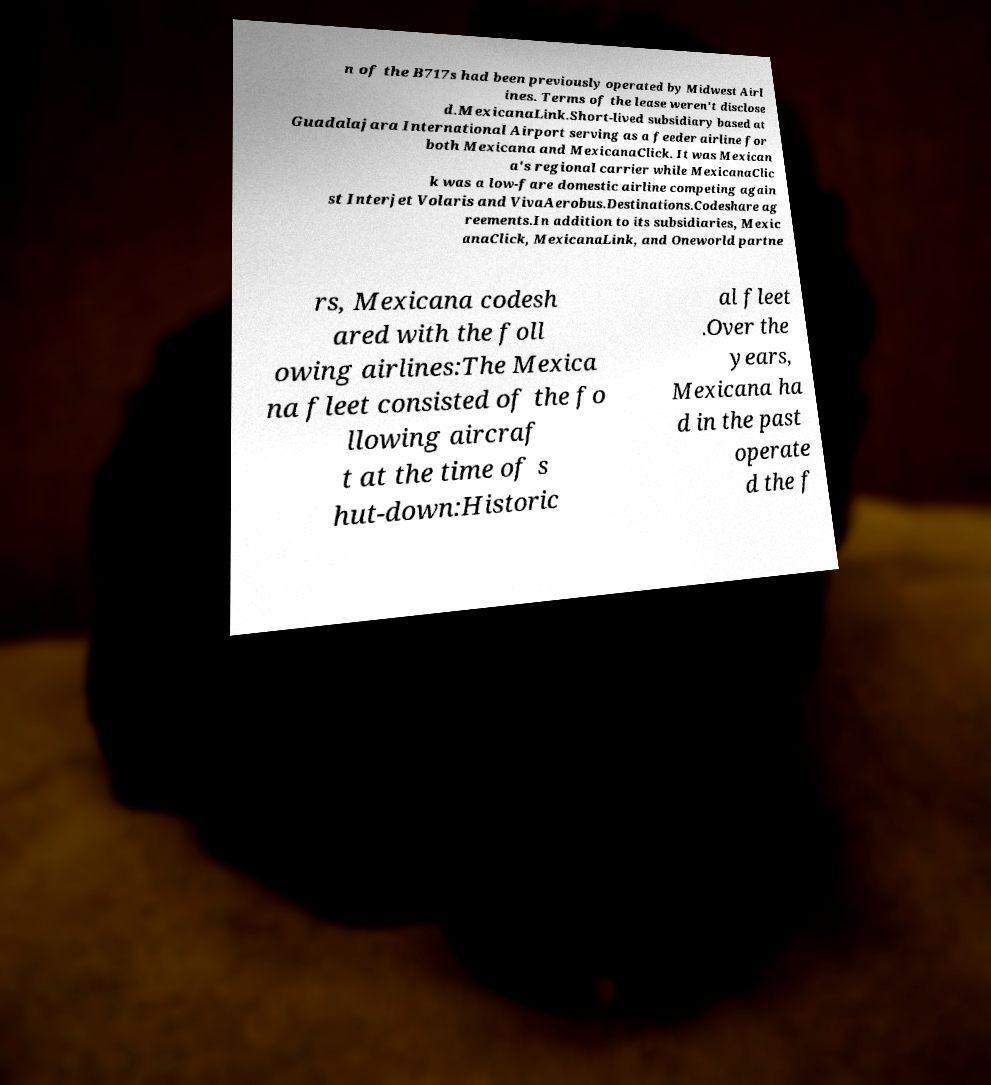Could you assist in decoding the text presented in this image and type it out clearly? n of the B717s had been previously operated by Midwest Airl ines. Terms of the lease weren't disclose d.MexicanaLink.Short-lived subsidiary based at Guadalajara International Airport serving as a feeder airline for both Mexicana and MexicanaClick. It was Mexican a's regional carrier while MexicanaClic k was a low-fare domestic airline competing again st Interjet Volaris and VivaAerobus.Destinations.Codeshare ag reements.In addition to its subsidiaries, Mexic anaClick, MexicanaLink, and Oneworld partne rs, Mexicana codesh ared with the foll owing airlines:The Mexica na fleet consisted of the fo llowing aircraf t at the time of s hut-down:Historic al fleet .Over the years, Mexicana ha d in the past operate d the f 